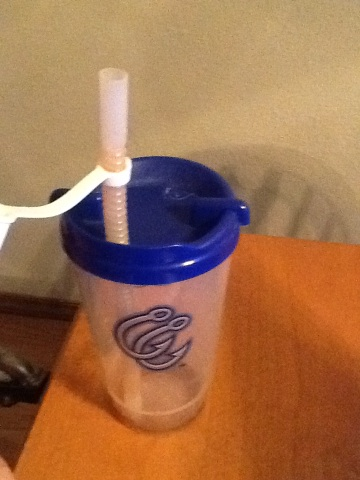Describe the functionality of the object in the image. The object in the image is a clear plastic mug with a blue lid and a flexible, white straw, designed for drinking convenience. It likely helps in avoiding spills and is suitable for both hot and cold beverages. 